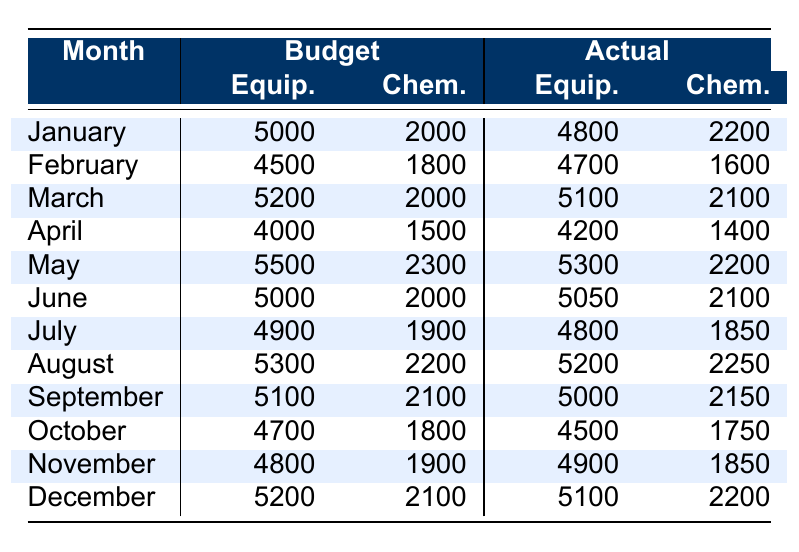What was the total budget for Equipment in March? The budget for Equipment in March is 5200. This value can be found directly in the table under the "Budget" column for March.
Answer: 5200 What was the actual expense on Chemicals in January? The actual expense on Chemicals in January is 2200. This value is taken directly from the "Actual" column for Chemicals in January.
Answer: 2200 Did the actual expenses for Chemicals in December exceed the budget? The budget for Chemicals in December is 2100, while the actual expenses were 2200. Since 2200 is greater than 2100, the actual expenses did exceed the budget.
Answer: Yes What was the difference in actual expenses for Equipment between January and February? The actual expenses for Equipment in January were 4800, and for February they were 4700. To find the difference, subtract February's expenses from January's: 4800 - 4700 = 100.
Answer: 100 What is the total actual expense for Utilities across all months? We will sum the actual expenses for Utilities from each month: 1450 + 1425 + 1580 + 1350 + 1650 + 1620 + 1500 + 1680 + 1600 + 1400 + 1520 + 1580 = 18875. Therefore, the total actual expenses for Utilities are 18875.
Answer: 18875 Was the actual expense for Staff Salaries consistent throughout the year? The actual expense for Staff Salaries was constant at 10000 for every month as reflected in the table. Since it remained unchanged every month, it shows consistency.
Answer: Yes Which month had the highest actual expense for Miscellaneous? The actual expenses for Miscellaneous are as follows: January 800, February 1300, March 950, April 950, May 1200, June 1050, July 1150, August 1300, September 1100, October 1200, November 1350, December 1200. The highest is 1350 in November.
Answer: November Calculate the average budget for Chemicals over the year. The budget for Chemicals across all months is: 2000 + 1800 + 2000 + 1500 + 2300 + 2000 + 1900 + 2200 + 2100 + 1800 + 1900 + 2100 = 22200. There are 12 months, so the average budget is 22200 / 12 = 1850.
Answer: 1850 What month had the largest difference between budget and actual expenses for Equipment? To determine the differences: January (200), February (100), March (100), April (200), May (200), June (50), July (100), August (100), September (100), October (200), November (-100), December (100). The largest difference is 200 for January, April, and October, but it's most pronounced in January and April in terms of over budget.
Answer: January and April 